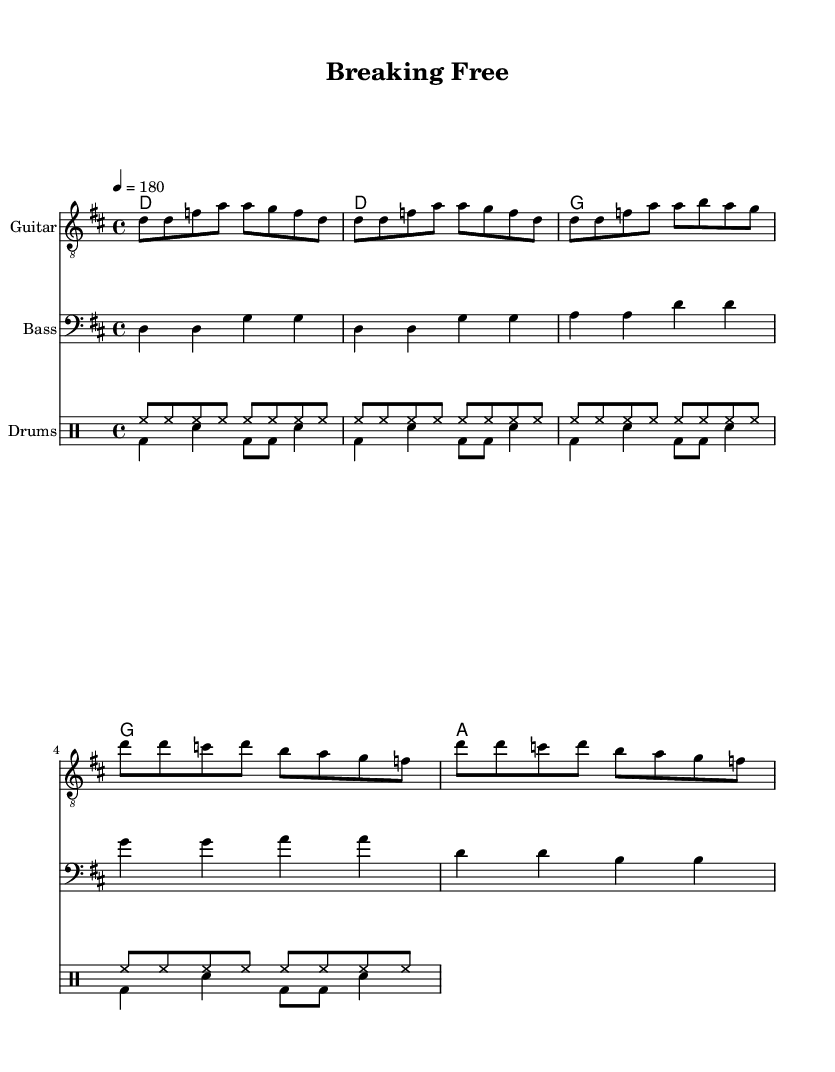What is the key signature of this music? The key signature is D major, which has two sharps (F# and C#). It can be identified by looking at the beginning of the staff where the sharps are indicated.
Answer: D major What is the time signature of this music? The time signature is 4/4, which means there are four beats in a measure and the quarter note gets one beat. This can be seen at the beginning of the staff next to the key signature.
Answer: 4/4 What is the tempo marking for this piece? The tempo marking is 180 beats per minute, indicated at the start of the score. This shows how fast the music should be played.
Answer: 180 How many measures are in the Chorus section? The Chorus section contains four measures. By counting the distinct sections in the chorus, which are primarily composed of repeated phrases, you can arrive at the measure count.
Answer: 4 What are the first two chords of the song? The first two chords are D and G. This can be determined by looking at the chord names written above the staff at the beginning of the piece.
Answer: D, G What is the genre of this piece? The genre of this piece is Punk, which is characterized by its fast-paced and energetic rhythm, as well as its themes of independence and freedom. These elements are typically found in the structure and style of the music reflected in the sheet.
Answer: Punk What type of drum is predominantly used in the song? The predominant drum used in the song is the bass drum. Looking at the drum part, especially in the pattern labeled "bd" (which stands for bass drum), it is featured prominently throughout the piece.
Answer: Bass drum 